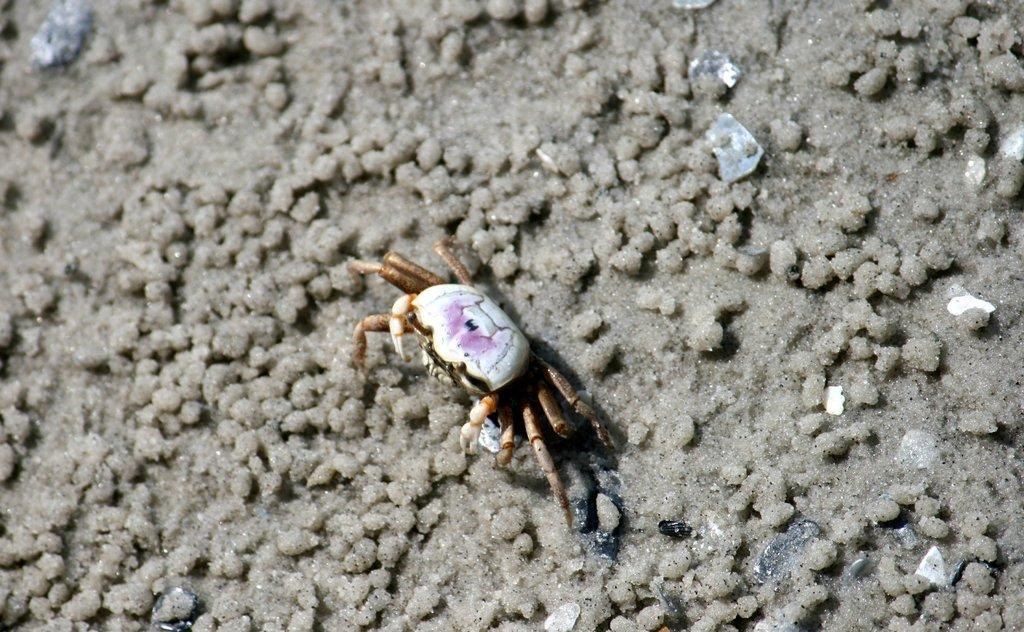What type of animal is in the image? There is a crab in the image. Where is the crab located in the image? The crab is on a path. What type of badge is the crab wearing in the image? There is no badge present in the image, as the crab is not wearing any clothing or accessories. What time is displayed on the clock in the image? There is no clock present in the image. 